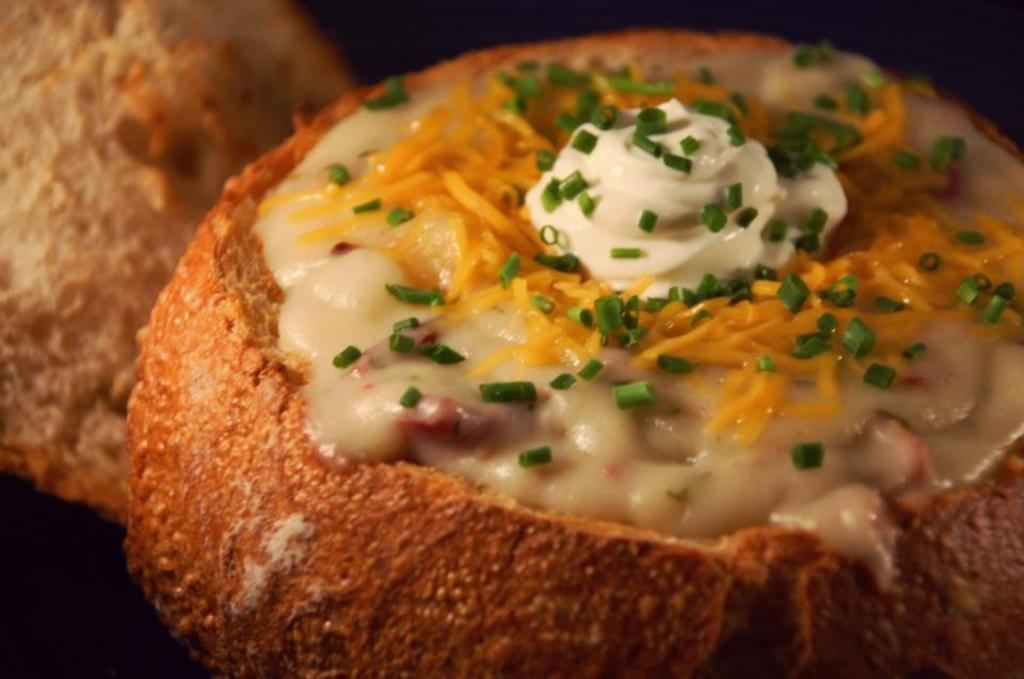What is the main subject of the image? The main subject of the image is food. Can you describe the background of the image? The background of the image is dark and blurry. What type of drum can be seen playing in the background of the image? There is no drum present in the image; the background is dark and blurry. How many toads are visible on the food in the image? There are no toads present in the image; it features food with no visible animals. 